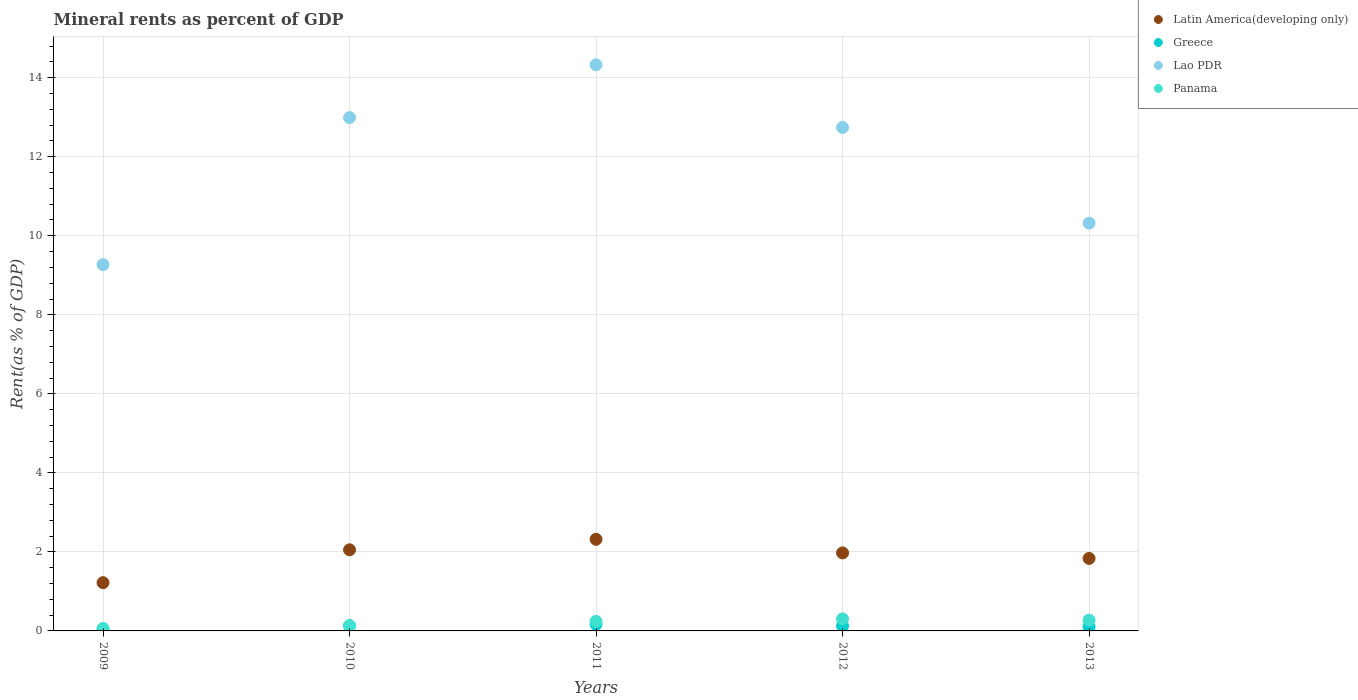Is the number of dotlines equal to the number of legend labels?
Provide a succinct answer. Yes. What is the mineral rent in Lao PDR in 2009?
Offer a terse response. 9.27. Across all years, what is the maximum mineral rent in Lao PDR?
Ensure brevity in your answer.  14.33. Across all years, what is the minimum mineral rent in Greece?
Your answer should be compact. 0.04. What is the total mineral rent in Panama in the graph?
Your response must be concise. 1.01. What is the difference between the mineral rent in Greece in 2010 and that in 2011?
Provide a short and direct response. -0.03. What is the difference between the mineral rent in Panama in 2011 and the mineral rent in Latin America(developing only) in 2010?
Your answer should be very brief. -1.81. What is the average mineral rent in Lao PDR per year?
Ensure brevity in your answer.  11.93. In the year 2011, what is the difference between the mineral rent in Lao PDR and mineral rent in Panama?
Give a very brief answer. 14.09. In how many years, is the mineral rent in Greece greater than 14.4 %?
Give a very brief answer. 0. What is the ratio of the mineral rent in Greece in 2010 to that in 2013?
Provide a succinct answer. 1.22. Is the mineral rent in Latin America(developing only) in 2011 less than that in 2013?
Make the answer very short. No. Is the difference between the mineral rent in Lao PDR in 2009 and 2011 greater than the difference between the mineral rent in Panama in 2009 and 2011?
Your answer should be compact. No. What is the difference between the highest and the second highest mineral rent in Greece?
Provide a succinct answer. 0.03. What is the difference between the highest and the lowest mineral rent in Lao PDR?
Provide a succinct answer. 5.06. Is it the case that in every year, the sum of the mineral rent in Greece and mineral rent in Panama  is greater than the mineral rent in Latin America(developing only)?
Keep it short and to the point. No. Does the mineral rent in Greece monotonically increase over the years?
Ensure brevity in your answer.  No. Is the mineral rent in Latin America(developing only) strictly less than the mineral rent in Lao PDR over the years?
Offer a very short reply. Yes. Are the values on the major ticks of Y-axis written in scientific E-notation?
Provide a short and direct response. No. Does the graph contain grids?
Ensure brevity in your answer.  Yes. Where does the legend appear in the graph?
Offer a terse response. Top right. What is the title of the graph?
Provide a succinct answer. Mineral rents as percent of GDP. What is the label or title of the Y-axis?
Ensure brevity in your answer.  Rent(as % of GDP). What is the Rent(as % of GDP) in Latin America(developing only) in 2009?
Provide a succinct answer. 1.22. What is the Rent(as % of GDP) of Greece in 2009?
Give a very brief answer. 0.04. What is the Rent(as % of GDP) of Lao PDR in 2009?
Offer a very short reply. 9.27. What is the Rent(as % of GDP) of Panama in 2009?
Your answer should be very brief. 0.06. What is the Rent(as % of GDP) of Latin America(developing only) in 2010?
Offer a terse response. 2.05. What is the Rent(as % of GDP) in Greece in 2010?
Provide a succinct answer. 0.13. What is the Rent(as % of GDP) in Lao PDR in 2010?
Your response must be concise. 12.99. What is the Rent(as % of GDP) in Panama in 2010?
Provide a short and direct response. 0.13. What is the Rent(as % of GDP) in Latin America(developing only) in 2011?
Provide a succinct answer. 2.32. What is the Rent(as % of GDP) in Greece in 2011?
Keep it short and to the point. 0.17. What is the Rent(as % of GDP) of Lao PDR in 2011?
Provide a succinct answer. 14.33. What is the Rent(as % of GDP) of Panama in 2011?
Provide a succinct answer. 0.24. What is the Rent(as % of GDP) in Latin America(developing only) in 2012?
Make the answer very short. 1.97. What is the Rent(as % of GDP) of Greece in 2012?
Keep it short and to the point. 0.13. What is the Rent(as % of GDP) of Lao PDR in 2012?
Provide a succinct answer. 12.74. What is the Rent(as % of GDP) in Panama in 2012?
Provide a short and direct response. 0.31. What is the Rent(as % of GDP) of Latin America(developing only) in 2013?
Give a very brief answer. 1.83. What is the Rent(as % of GDP) in Greece in 2013?
Provide a succinct answer. 0.11. What is the Rent(as % of GDP) in Lao PDR in 2013?
Ensure brevity in your answer.  10.32. What is the Rent(as % of GDP) in Panama in 2013?
Offer a very short reply. 0.27. Across all years, what is the maximum Rent(as % of GDP) of Latin America(developing only)?
Your response must be concise. 2.32. Across all years, what is the maximum Rent(as % of GDP) in Greece?
Offer a terse response. 0.17. Across all years, what is the maximum Rent(as % of GDP) in Lao PDR?
Offer a terse response. 14.33. Across all years, what is the maximum Rent(as % of GDP) of Panama?
Ensure brevity in your answer.  0.31. Across all years, what is the minimum Rent(as % of GDP) of Latin America(developing only)?
Offer a very short reply. 1.22. Across all years, what is the minimum Rent(as % of GDP) in Greece?
Your answer should be compact. 0.04. Across all years, what is the minimum Rent(as % of GDP) in Lao PDR?
Your response must be concise. 9.27. Across all years, what is the minimum Rent(as % of GDP) in Panama?
Your response must be concise. 0.06. What is the total Rent(as % of GDP) in Latin America(developing only) in the graph?
Ensure brevity in your answer.  9.4. What is the total Rent(as % of GDP) of Greece in the graph?
Your answer should be compact. 0.58. What is the total Rent(as % of GDP) of Lao PDR in the graph?
Your answer should be compact. 59.65. What is the total Rent(as % of GDP) in Panama in the graph?
Give a very brief answer. 1.01. What is the difference between the Rent(as % of GDP) of Latin America(developing only) in 2009 and that in 2010?
Your response must be concise. -0.83. What is the difference between the Rent(as % of GDP) in Greece in 2009 and that in 2010?
Offer a very short reply. -0.09. What is the difference between the Rent(as % of GDP) in Lao PDR in 2009 and that in 2010?
Ensure brevity in your answer.  -3.72. What is the difference between the Rent(as % of GDP) of Panama in 2009 and that in 2010?
Keep it short and to the point. -0.06. What is the difference between the Rent(as % of GDP) of Latin America(developing only) in 2009 and that in 2011?
Your answer should be very brief. -1.1. What is the difference between the Rent(as % of GDP) in Greece in 2009 and that in 2011?
Ensure brevity in your answer.  -0.12. What is the difference between the Rent(as % of GDP) of Lao PDR in 2009 and that in 2011?
Give a very brief answer. -5.06. What is the difference between the Rent(as % of GDP) in Panama in 2009 and that in 2011?
Give a very brief answer. -0.18. What is the difference between the Rent(as % of GDP) in Latin America(developing only) in 2009 and that in 2012?
Keep it short and to the point. -0.75. What is the difference between the Rent(as % of GDP) in Greece in 2009 and that in 2012?
Provide a succinct answer. -0.08. What is the difference between the Rent(as % of GDP) of Lao PDR in 2009 and that in 2012?
Provide a succinct answer. -3.47. What is the difference between the Rent(as % of GDP) of Panama in 2009 and that in 2012?
Offer a very short reply. -0.24. What is the difference between the Rent(as % of GDP) in Latin America(developing only) in 2009 and that in 2013?
Make the answer very short. -0.61. What is the difference between the Rent(as % of GDP) in Greece in 2009 and that in 2013?
Make the answer very short. -0.07. What is the difference between the Rent(as % of GDP) of Lao PDR in 2009 and that in 2013?
Make the answer very short. -1.05. What is the difference between the Rent(as % of GDP) in Panama in 2009 and that in 2013?
Your answer should be compact. -0.21. What is the difference between the Rent(as % of GDP) of Latin America(developing only) in 2010 and that in 2011?
Your answer should be very brief. -0.27. What is the difference between the Rent(as % of GDP) in Greece in 2010 and that in 2011?
Provide a succinct answer. -0.03. What is the difference between the Rent(as % of GDP) of Lao PDR in 2010 and that in 2011?
Offer a very short reply. -1.34. What is the difference between the Rent(as % of GDP) of Panama in 2010 and that in 2011?
Ensure brevity in your answer.  -0.11. What is the difference between the Rent(as % of GDP) of Latin America(developing only) in 2010 and that in 2012?
Your response must be concise. 0.08. What is the difference between the Rent(as % of GDP) in Greece in 2010 and that in 2012?
Your answer should be very brief. 0.01. What is the difference between the Rent(as % of GDP) in Lao PDR in 2010 and that in 2012?
Give a very brief answer. 0.25. What is the difference between the Rent(as % of GDP) in Panama in 2010 and that in 2012?
Keep it short and to the point. -0.18. What is the difference between the Rent(as % of GDP) of Latin America(developing only) in 2010 and that in 2013?
Ensure brevity in your answer.  0.22. What is the difference between the Rent(as % of GDP) of Greece in 2010 and that in 2013?
Give a very brief answer. 0.02. What is the difference between the Rent(as % of GDP) in Lao PDR in 2010 and that in 2013?
Your response must be concise. 2.67. What is the difference between the Rent(as % of GDP) of Panama in 2010 and that in 2013?
Your answer should be very brief. -0.14. What is the difference between the Rent(as % of GDP) in Latin America(developing only) in 2011 and that in 2012?
Give a very brief answer. 0.34. What is the difference between the Rent(as % of GDP) in Greece in 2011 and that in 2012?
Offer a terse response. 0.04. What is the difference between the Rent(as % of GDP) in Lao PDR in 2011 and that in 2012?
Give a very brief answer. 1.59. What is the difference between the Rent(as % of GDP) of Panama in 2011 and that in 2012?
Your response must be concise. -0.06. What is the difference between the Rent(as % of GDP) in Latin America(developing only) in 2011 and that in 2013?
Give a very brief answer. 0.48. What is the difference between the Rent(as % of GDP) of Greece in 2011 and that in 2013?
Offer a very short reply. 0.06. What is the difference between the Rent(as % of GDP) of Lao PDR in 2011 and that in 2013?
Offer a very short reply. 4.01. What is the difference between the Rent(as % of GDP) of Panama in 2011 and that in 2013?
Make the answer very short. -0.03. What is the difference between the Rent(as % of GDP) of Latin America(developing only) in 2012 and that in 2013?
Offer a terse response. 0.14. What is the difference between the Rent(as % of GDP) in Greece in 2012 and that in 2013?
Provide a succinct answer. 0.02. What is the difference between the Rent(as % of GDP) in Lao PDR in 2012 and that in 2013?
Offer a terse response. 2.42. What is the difference between the Rent(as % of GDP) of Panama in 2012 and that in 2013?
Offer a terse response. 0.03. What is the difference between the Rent(as % of GDP) of Latin America(developing only) in 2009 and the Rent(as % of GDP) of Greece in 2010?
Ensure brevity in your answer.  1.09. What is the difference between the Rent(as % of GDP) in Latin America(developing only) in 2009 and the Rent(as % of GDP) in Lao PDR in 2010?
Provide a short and direct response. -11.77. What is the difference between the Rent(as % of GDP) in Latin America(developing only) in 2009 and the Rent(as % of GDP) in Panama in 2010?
Your answer should be very brief. 1.09. What is the difference between the Rent(as % of GDP) of Greece in 2009 and the Rent(as % of GDP) of Lao PDR in 2010?
Provide a succinct answer. -12.95. What is the difference between the Rent(as % of GDP) in Greece in 2009 and the Rent(as % of GDP) in Panama in 2010?
Keep it short and to the point. -0.08. What is the difference between the Rent(as % of GDP) in Lao PDR in 2009 and the Rent(as % of GDP) in Panama in 2010?
Your answer should be very brief. 9.14. What is the difference between the Rent(as % of GDP) of Latin America(developing only) in 2009 and the Rent(as % of GDP) of Greece in 2011?
Your answer should be compact. 1.05. What is the difference between the Rent(as % of GDP) of Latin America(developing only) in 2009 and the Rent(as % of GDP) of Lao PDR in 2011?
Offer a terse response. -13.11. What is the difference between the Rent(as % of GDP) in Latin America(developing only) in 2009 and the Rent(as % of GDP) in Panama in 2011?
Ensure brevity in your answer.  0.98. What is the difference between the Rent(as % of GDP) of Greece in 2009 and the Rent(as % of GDP) of Lao PDR in 2011?
Provide a short and direct response. -14.28. What is the difference between the Rent(as % of GDP) of Greece in 2009 and the Rent(as % of GDP) of Panama in 2011?
Ensure brevity in your answer.  -0.2. What is the difference between the Rent(as % of GDP) in Lao PDR in 2009 and the Rent(as % of GDP) in Panama in 2011?
Offer a terse response. 9.03. What is the difference between the Rent(as % of GDP) of Latin America(developing only) in 2009 and the Rent(as % of GDP) of Greece in 2012?
Offer a terse response. 1.09. What is the difference between the Rent(as % of GDP) in Latin America(developing only) in 2009 and the Rent(as % of GDP) in Lao PDR in 2012?
Your response must be concise. -11.52. What is the difference between the Rent(as % of GDP) of Latin America(developing only) in 2009 and the Rent(as % of GDP) of Panama in 2012?
Provide a short and direct response. 0.92. What is the difference between the Rent(as % of GDP) in Greece in 2009 and the Rent(as % of GDP) in Lao PDR in 2012?
Provide a succinct answer. -12.7. What is the difference between the Rent(as % of GDP) in Greece in 2009 and the Rent(as % of GDP) in Panama in 2012?
Offer a terse response. -0.26. What is the difference between the Rent(as % of GDP) in Lao PDR in 2009 and the Rent(as % of GDP) in Panama in 2012?
Offer a terse response. 8.96. What is the difference between the Rent(as % of GDP) of Latin America(developing only) in 2009 and the Rent(as % of GDP) of Lao PDR in 2013?
Provide a short and direct response. -9.1. What is the difference between the Rent(as % of GDP) of Latin America(developing only) in 2009 and the Rent(as % of GDP) of Panama in 2013?
Offer a very short reply. 0.95. What is the difference between the Rent(as % of GDP) in Greece in 2009 and the Rent(as % of GDP) in Lao PDR in 2013?
Offer a terse response. -10.28. What is the difference between the Rent(as % of GDP) in Greece in 2009 and the Rent(as % of GDP) in Panama in 2013?
Keep it short and to the point. -0.23. What is the difference between the Rent(as % of GDP) in Lao PDR in 2009 and the Rent(as % of GDP) in Panama in 2013?
Provide a short and direct response. 9. What is the difference between the Rent(as % of GDP) of Latin America(developing only) in 2010 and the Rent(as % of GDP) of Greece in 2011?
Provide a succinct answer. 1.89. What is the difference between the Rent(as % of GDP) in Latin America(developing only) in 2010 and the Rent(as % of GDP) in Lao PDR in 2011?
Offer a terse response. -12.28. What is the difference between the Rent(as % of GDP) of Latin America(developing only) in 2010 and the Rent(as % of GDP) of Panama in 2011?
Offer a very short reply. 1.81. What is the difference between the Rent(as % of GDP) in Greece in 2010 and the Rent(as % of GDP) in Lao PDR in 2011?
Your answer should be very brief. -14.19. What is the difference between the Rent(as % of GDP) in Greece in 2010 and the Rent(as % of GDP) in Panama in 2011?
Ensure brevity in your answer.  -0.11. What is the difference between the Rent(as % of GDP) of Lao PDR in 2010 and the Rent(as % of GDP) of Panama in 2011?
Keep it short and to the point. 12.75. What is the difference between the Rent(as % of GDP) in Latin America(developing only) in 2010 and the Rent(as % of GDP) in Greece in 2012?
Offer a very short reply. 1.92. What is the difference between the Rent(as % of GDP) of Latin America(developing only) in 2010 and the Rent(as % of GDP) of Lao PDR in 2012?
Provide a short and direct response. -10.69. What is the difference between the Rent(as % of GDP) of Latin America(developing only) in 2010 and the Rent(as % of GDP) of Panama in 2012?
Your answer should be very brief. 1.75. What is the difference between the Rent(as % of GDP) in Greece in 2010 and the Rent(as % of GDP) in Lao PDR in 2012?
Give a very brief answer. -12.61. What is the difference between the Rent(as % of GDP) of Greece in 2010 and the Rent(as % of GDP) of Panama in 2012?
Offer a terse response. -0.17. What is the difference between the Rent(as % of GDP) in Lao PDR in 2010 and the Rent(as % of GDP) in Panama in 2012?
Offer a terse response. 12.69. What is the difference between the Rent(as % of GDP) in Latin America(developing only) in 2010 and the Rent(as % of GDP) in Greece in 2013?
Your answer should be very brief. 1.94. What is the difference between the Rent(as % of GDP) of Latin America(developing only) in 2010 and the Rent(as % of GDP) of Lao PDR in 2013?
Make the answer very short. -8.27. What is the difference between the Rent(as % of GDP) of Latin America(developing only) in 2010 and the Rent(as % of GDP) of Panama in 2013?
Give a very brief answer. 1.78. What is the difference between the Rent(as % of GDP) in Greece in 2010 and the Rent(as % of GDP) in Lao PDR in 2013?
Make the answer very short. -10.19. What is the difference between the Rent(as % of GDP) in Greece in 2010 and the Rent(as % of GDP) in Panama in 2013?
Make the answer very short. -0.14. What is the difference between the Rent(as % of GDP) in Lao PDR in 2010 and the Rent(as % of GDP) in Panama in 2013?
Ensure brevity in your answer.  12.72. What is the difference between the Rent(as % of GDP) of Latin America(developing only) in 2011 and the Rent(as % of GDP) of Greece in 2012?
Keep it short and to the point. 2.19. What is the difference between the Rent(as % of GDP) in Latin America(developing only) in 2011 and the Rent(as % of GDP) in Lao PDR in 2012?
Your answer should be very brief. -10.42. What is the difference between the Rent(as % of GDP) of Latin America(developing only) in 2011 and the Rent(as % of GDP) of Panama in 2012?
Give a very brief answer. 2.01. What is the difference between the Rent(as % of GDP) of Greece in 2011 and the Rent(as % of GDP) of Lao PDR in 2012?
Offer a very short reply. -12.57. What is the difference between the Rent(as % of GDP) in Greece in 2011 and the Rent(as % of GDP) in Panama in 2012?
Your answer should be very brief. -0.14. What is the difference between the Rent(as % of GDP) of Lao PDR in 2011 and the Rent(as % of GDP) of Panama in 2012?
Your answer should be compact. 14.02. What is the difference between the Rent(as % of GDP) of Latin America(developing only) in 2011 and the Rent(as % of GDP) of Greece in 2013?
Ensure brevity in your answer.  2.21. What is the difference between the Rent(as % of GDP) in Latin America(developing only) in 2011 and the Rent(as % of GDP) in Lao PDR in 2013?
Ensure brevity in your answer.  -8. What is the difference between the Rent(as % of GDP) of Latin America(developing only) in 2011 and the Rent(as % of GDP) of Panama in 2013?
Offer a very short reply. 2.05. What is the difference between the Rent(as % of GDP) in Greece in 2011 and the Rent(as % of GDP) in Lao PDR in 2013?
Provide a short and direct response. -10.15. What is the difference between the Rent(as % of GDP) in Greece in 2011 and the Rent(as % of GDP) in Panama in 2013?
Your response must be concise. -0.11. What is the difference between the Rent(as % of GDP) of Lao PDR in 2011 and the Rent(as % of GDP) of Panama in 2013?
Your answer should be very brief. 14.06. What is the difference between the Rent(as % of GDP) in Latin America(developing only) in 2012 and the Rent(as % of GDP) in Greece in 2013?
Your answer should be compact. 1.86. What is the difference between the Rent(as % of GDP) of Latin America(developing only) in 2012 and the Rent(as % of GDP) of Lao PDR in 2013?
Offer a very short reply. -8.35. What is the difference between the Rent(as % of GDP) in Latin America(developing only) in 2012 and the Rent(as % of GDP) in Panama in 2013?
Make the answer very short. 1.7. What is the difference between the Rent(as % of GDP) of Greece in 2012 and the Rent(as % of GDP) of Lao PDR in 2013?
Offer a terse response. -10.19. What is the difference between the Rent(as % of GDP) of Greece in 2012 and the Rent(as % of GDP) of Panama in 2013?
Make the answer very short. -0.14. What is the difference between the Rent(as % of GDP) in Lao PDR in 2012 and the Rent(as % of GDP) in Panama in 2013?
Keep it short and to the point. 12.47. What is the average Rent(as % of GDP) in Latin America(developing only) per year?
Provide a succinct answer. 1.88. What is the average Rent(as % of GDP) in Greece per year?
Offer a very short reply. 0.12. What is the average Rent(as % of GDP) of Lao PDR per year?
Keep it short and to the point. 11.93. What is the average Rent(as % of GDP) of Panama per year?
Provide a short and direct response. 0.2. In the year 2009, what is the difference between the Rent(as % of GDP) in Latin America(developing only) and Rent(as % of GDP) in Greece?
Offer a very short reply. 1.18. In the year 2009, what is the difference between the Rent(as % of GDP) in Latin America(developing only) and Rent(as % of GDP) in Lao PDR?
Ensure brevity in your answer.  -8.05. In the year 2009, what is the difference between the Rent(as % of GDP) of Latin America(developing only) and Rent(as % of GDP) of Panama?
Offer a very short reply. 1.16. In the year 2009, what is the difference between the Rent(as % of GDP) of Greece and Rent(as % of GDP) of Lao PDR?
Your response must be concise. -9.23. In the year 2009, what is the difference between the Rent(as % of GDP) in Greece and Rent(as % of GDP) in Panama?
Your response must be concise. -0.02. In the year 2009, what is the difference between the Rent(as % of GDP) in Lao PDR and Rent(as % of GDP) in Panama?
Your answer should be compact. 9.21. In the year 2010, what is the difference between the Rent(as % of GDP) of Latin America(developing only) and Rent(as % of GDP) of Greece?
Your response must be concise. 1.92. In the year 2010, what is the difference between the Rent(as % of GDP) of Latin America(developing only) and Rent(as % of GDP) of Lao PDR?
Offer a terse response. -10.94. In the year 2010, what is the difference between the Rent(as % of GDP) in Latin America(developing only) and Rent(as % of GDP) in Panama?
Offer a terse response. 1.93. In the year 2010, what is the difference between the Rent(as % of GDP) in Greece and Rent(as % of GDP) in Lao PDR?
Offer a terse response. -12.86. In the year 2010, what is the difference between the Rent(as % of GDP) of Greece and Rent(as % of GDP) of Panama?
Keep it short and to the point. 0.01. In the year 2010, what is the difference between the Rent(as % of GDP) of Lao PDR and Rent(as % of GDP) of Panama?
Make the answer very short. 12.86. In the year 2011, what is the difference between the Rent(as % of GDP) of Latin America(developing only) and Rent(as % of GDP) of Greece?
Keep it short and to the point. 2.15. In the year 2011, what is the difference between the Rent(as % of GDP) of Latin America(developing only) and Rent(as % of GDP) of Lao PDR?
Your response must be concise. -12.01. In the year 2011, what is the difference between the Rent(as % of GDP) of Latin America(developing only) and Rent(as % of GDP) of Panama?
Offer a terse response. 2.08. In the year 2011, what is the difference between the Rent(as % of GDP) of Greece and Rent(as % of GDP) of Lao PDR?
Give a very brief answer. -14.16. In the year 2011, what is the difference between the Rent(as % of GDP) in Greece and Rent(as % of GDP) in Panama?
Provide a succinct answer. -0.08. In the year 2011, what is the difference between the Rent(as % of GDP) in Lao PDR and Rent(as % of GDP) in Panama?
Your answer should be very brief. 14.09. In the year 2012, what is the difference between the Rent(as % of GDP) of Latin America(developing only) and Rent(as % of GDP) of Greece?
Ensure brevity in your answer.  1.85. In the year 2012, what is the difference between the Rent(as % of GDP) of Latin America(developing only) and Rent(as % of GDP) of Lao PDR?
Make the answer very short. -10.77. In the year 2012, what is the difference between the Rent(as % of GDP) in Latin America(developing only) and Rent(as % of GDP) in Panama?
Make the answer very short. 1.67. In the year 2012, what is the difference between the Rent(as % of GDP) of Greece and Rent(as % of GDP) of Lao PDR?
Keep it short and to the point. -12.61. In the year 2012, what is the difference between the Rent(as % of GDP) of Greece and Rent(as % of GDP) of Panama?
Your response must be concise. -0.18. In the year 2012, what is the difference between the Rent(as % of GDP) of Lao PDR and Rent(as % of GDP) of Panama?
Provide a short and direct response. 12.44. In the year 2013, what is the difference between the Rent(as % of GDP) of Latin America(developing only) and Rent(as % of GDP) of Greece?
Your answer should be compact. 1.72. In the year 2013, what is the difference between the Rent(as % of GDP) of Latin America(developing only) and Rent(as % of GDP) of Lao PDR?
Your answer should be very brief. -8.48. In the year 2013, what is the difference between the Rent(as % of GDP) in Latin America(developing only) and Rent(as % of GDP) in Panama?
Your answer should be very brief. 1.56. In the year 2013, what is the difference between the Rent(as % of GDP) of Greece and Rent(as % of GDP) of Lao PDR?
Provide a short and direct response. -10.21. In the year 2013, what is the difference between the Rent(as % of GDP) in Greece and Rent(as % of GDP) in Panama?
Provide a short and direct response. -0.16. In the year 2013, what is the difference between the Rent(as % of GDP) in Lao PDR and Rent(as % of GDP) in Panama?
Provide a short and direct response. 10.05. What is the ratio of the Rent(as % of GDP) in Latin America(developing only) in 2009 to that in 2010?
Provide a succinct answer. 0.59. What is the ratio of the Rent(as % of GDP) of Greece in 2009 to that in 2010?
Offer a terse response. 0.33. What is the ratio of the Rent(as % of GDP) in Lao PDR in 2009 to that in 2010?
Your answer should be very brief. 0.71. What is the ratio of the Rent(as % of GDP) of Panama in 2009 to that in 2010?
Keep it short and to the point. 0.5. What is the ratio of the Rent(as % of GDP) in Latin America(developing only) in 2009 to that in 2011?
Give a very brief answer. 0.53. What is the ratio of the Rent(as % of GDP) of Greece in 2009 to that in 2011?
Your answer should be very brief. 0.26. What is the ratio of the Rent(as % of GDP) in Lao PDR in 2009 to that in 2011?
Make the answer very short. 0.65. What is the ratio of the Rent(as % of GDP) in Panama in 2009 to that in 2011?
Offer a terse response. 0.26. What is the ratio of the Rent(as % of GDP) of Latin America(developing only) in 2009 to that in 2012?
Keep it short and to the point. 0.62. What is the ratio of the Rent(as % of GDP) of Greece in 2009 to that in 2012?
Your answer should be compact. 0.34. What is the ratio of the Rent(as % of GDP) in Lao PDR in 2009 to that in 2012?
Your answer should be compact. 0.73. What is the ratio of the Rent(as % of GDP) of Panama in 2009 to that in 2012?
Offer a terse response. 0.21. What is the ratio of the Rent(as % of GDP) of Latin America(developing only) in 2009 to that in 2013?
Give a very brief answer. 0.67. What is the ratio of the Rent(as % of GDP) in Greece in 2009 to that in 2013?
Your answer should be compact. 0.4. What is the ratio of the Rent(as % of GDP) in Lao PDR in 2009 to that in 2013?
Your answer should be very brief. 0.9. What is the ratio of the Rent(as % of GDP) in Panama in 2009 to that in 2013?
Offer a terse response. 0.23. What is the ratio of the Rent(as % of GDP) in Latin America(developing only) in 2010 to that in 2011?
Ensure brevity in your answer.  0.89. What is the ratio of the Rent(as % of GDP) in Greece in 2010 to that in 2011?
Your answer should be compact. 0.8. What is the ratio of the Rent(as % of GDP) of Lao PDR in 2010 to that in 2011?
Offer a very short reply. 0.91. What is the ratio of the Rent(as % of GDP) of Panama in 2010 to that in 2011?
Offer a very short reply. 0.53. What is the ratio of the Rent(as % of GDP) in Latin America(developing only) in 2010 to that in 2012?
Ensure brevity in your answer.  1.04. What is the ratio of the Rent(as % of GDP) of Greece in 2010 to that in 2012?
Provide a succinct answer. 1.04. What is the ratio of the Rent(as % of GDP) in Lao PDR in 2010 to that in 2012?
Offer a very short reply. 1.02. What is the ratio of the Rent(as % of GDP) of Panama in 2010 to that in 2012?
Offer a terse response. 0.42. What is the ratio of the Rent(as % of GDP) of Latin America(developing only) in 2010 to that in 2013?
Give a very brief answer. 1.12. What is the ratio of the Rent(as % of GDP) of Greece in 2010 to that in 2013?
Your answer should be compact. 1.22. What is the ratio of the Rent(as % of GDP) in Lao PDR in 2010 to that in 2013?
Your answer should be compact. 1.26. What is the ratio of the Rent(as % of GDP) of Panama in 2010 to that in 2013?
Your response must be concise. 0.47. What is the ratio of the Rent(as % of GDP) in Latin America(developing only) in 2011 to that in 2012?
Your answer should be very brief. 1.17. What is the ratio of the Rent(as % of GDP) in Greece in 2011 to that in 2012?
Ensure brevity in your answer.  1.3. What is the ratio of the Rent(as % of GDP) of Lao PDR in 2011 to that in 2012?
Offer a very short reply. 1.12. What is the ratio of the Rent(as % of GDP) in Panama in 2011 to that in 2012?
Provide a succinct answer. 0.79. What is the ratio of the Rent(as % of GDP) of Latin America(developing only) in 2011 to that in 2013?
Make the answer very short. 1.26. What is the ratio of the Rent(as % of GDP) in Greece in 2011 to that in 2013?
Ensure brevity in your answer.  1.51. What is the ratio of the Rent(as % of GDP) of Lao PDR in 2011 to that in 2013?
Give a very brief answer. 1.39. What is the ratio of the Rent(as % of GDP) of Panama in 2011 to that in 2013?
Keep it short and to the point. 0.89. What is the ratio of the Rent(as % of GDP) of Latin America(developing only) in 2012 to that in 2013?
Offer a terse response. 1.08. What is the ratio of the Rent(as % of GDP) in Greece in 2012 to that in 2013?
Keep it short and to the point. 1.17. What is the ratio of the Rent(as % of GDP) in Lao PDR in 2012 to that in 2013?
Make the answer very short. 1.23. What is the ratio of the Rent(as % of GDP) of Panama in 2012 to that in 2013?
Make the answer very short. 1.12. What is the difference between the highest and the second highest Rent(as % of GDP) of Latin America(developing only)?
Keep it short and to the point. 0.27. What is the difference between the highest and the second highest Rent(as % of GDP) of Greece?
Ensure brevity in your answer.  0.03. What is the difference between the highest and the second highest Rent(as % of GDP) in Lao PDR?
Offer a very short reply. 1.34. What is the difference between the highest and the second highest Rent(as % of GDP) of Panama?
Provide a short and direct response. 0.03. What is the difference between the highest and the lowest Rent(as % of GDP) of Latin America(developing only)?
Your answer should be very brief. 1.1. What is the difference between the highest and the lowest Rent(as % of GDP) in Greece?
Your answer should be compact. 0.12. What is the difference between the highest and the lowest Rent(as % of GDP) of Lao PDR?
Make the answer very short. 5.06. What is the difference between the highest and the lowest Rent(as % of GDP) of Panama?
Keep it short and to the point. 0.24. 